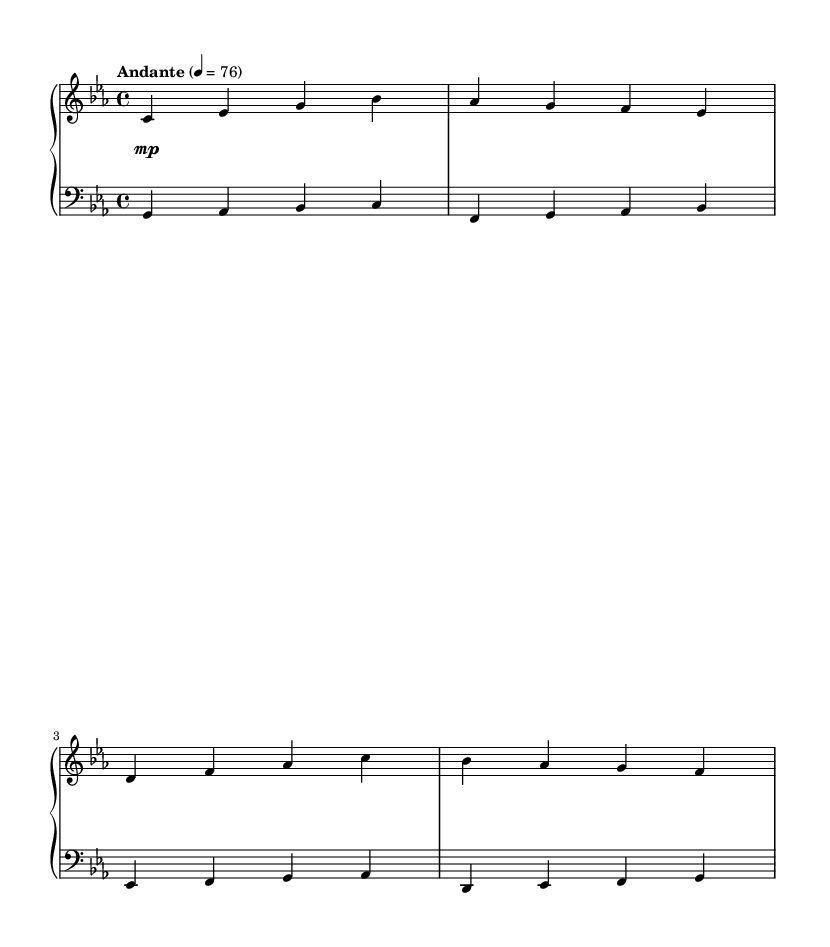What is the key signature of this music? The key signature is indicated at the beginning of the staff; here, it shows three flats which correspond to the key of C minor.
Answer: C minor What is the time signature of this piece? The time signature is placed at the start of the music; it shows a 4 over 4, meaning there are four beats in each measure, and the quarter note gets one beat.
Answer: 4/4 What is the tempo marking for this composition? The tempo marking is found at the beginning, where it states "Andante" with a metronome marking of 76. "Andante" indicates a moderately slow tempo.
Answer: Andante What melodic theme appears prominently in the right hand? By examining the notes in the right hand, the sequence of pitches played collectively forms the main theme. The right hand is playing the main melody throughout.
Answer: Main Theme How many measures are in the provided music? By counting the individual bars separated by vertical lines, we can identify the number of measures present; there are twelve measures visible in the sheet music.
Answer: 12 What dynamic marking is indicated for the piano section? The dynamics are specifically indicated below the staff; the marking shows a soft performance level indicated by "mp". This means "mezzo piano" or moderately soft.
Answer: mp What is the role of the left hand in this piece? The left hand primarily provides a counter melody to the main theme in the right hand, outlined by the pitches and rhythm present in that staff. It supports the overall harmony in a classical context.
Answer: Counter Melody 